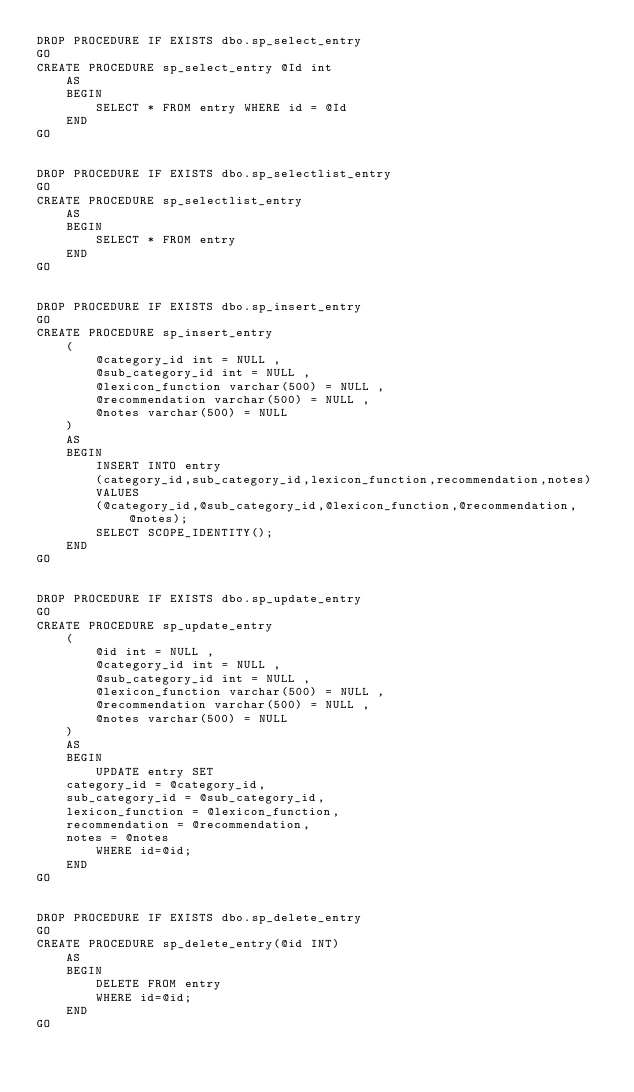<code> <loc_0><loc_0><loc_500><loc_500><_SQL_>DROP PROCEDURE IF EXISTS dbo.sp_select_entry
GO
CREATE PROCEDURE sp_select_entry @Id int
    AS
    BEGIN
        SELECT * FROM entry WHERE id = @Id
    END
GO


DROP PROCEDURE IF EXISTS dbo.sp_selectlist_entry
GO
CREATE PROCEDURE sp_selectlist_entry
    AS
    BEGIN
        SELECT * FROM entry
    END
GO


DROP PROCEDURE IF EXISTS dbo.sp_insert_entry
GO
CREATE PROCEDURE sp_insert_entry
    (
        @category_id int = NULL ,
        @sub_category_id int = NULL ,
        @lexicon_function varchar(500) = NULL ,
        @recommendation varchar(500) = NULL ,
        @notes varchar(500) = NULL 
    )
    AS
    BEGIN
        INSERT INTO entry
        (category_id,sub_category_id,lexicon_function,recommendation,notes)
        VALUES
        (@category_id,@sub_category_id,@lexicon_function,@recommendation,@notes);
        SELECT SCOPE_IDENTITY();
    END
GO


DROP PROCEDURE IF EXISTS dbo.sp_update_entry
GO
CREATE PROCEDURE sp_update_entry
    (
        @id int = NULL ,
        @category_id int = NULL ,
        @sub_category_id int = NULL ,
        @lexicon_function varchar(500) = NULL ,
        @recommendation varchar(500) = NULL ,
        @notes varchar(500) = NULL 
    )
    AS
    BEGIN
        UPDATE entry SET
    category_id = @category_id,
    sub_category_id = @sub_category_id,
    lexicon_function = @lexicon_function,
    recommendation = @recommendation,
    notes = @notes
        WHERE id=@id;
    END
GO


DROP PROCEDURE IF EXISTS dbo.sp_delete_entry
GO
CREATE PROCEDURE sp_delete_entry(@id INT)
    AS
    BEGIN
        DELETE FROM entry
        WHERE id=@id;
    END
GO
</code> 